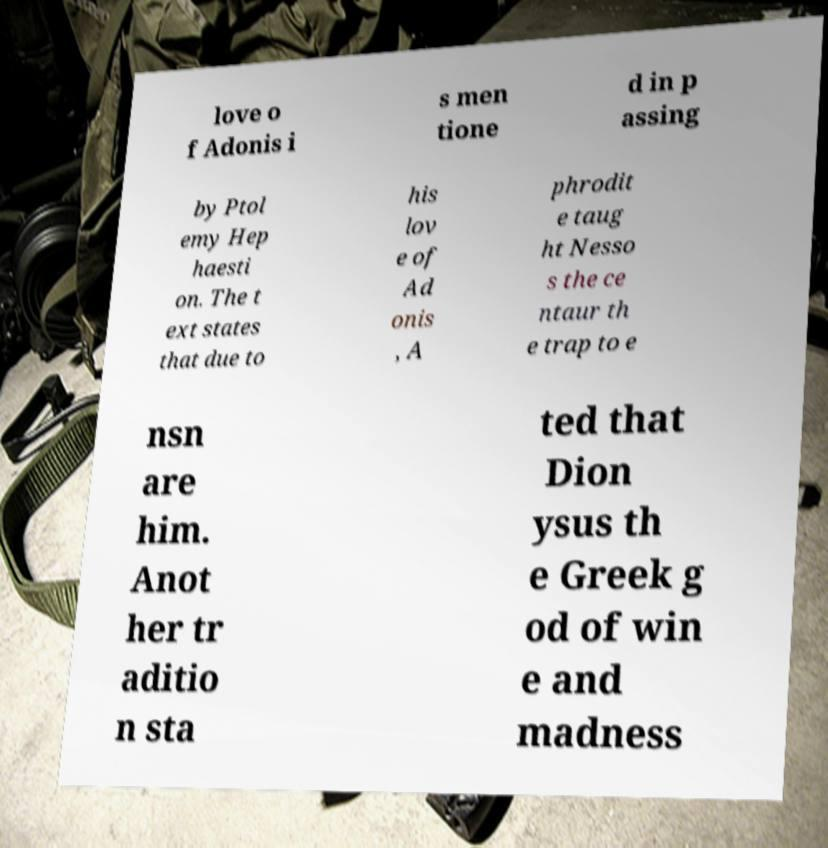For documentation purposes, I need the text within this image transcribed. Could you provide that? love o f Adonis i s men tione d in p assing by Ptol emy Hep haesti on. The t ext states that due to his lov e of Ad onis , A phrodit e taug ht Nesso s the ce ntaur th e trap to e nsn are him. Anot her tr aditio n sta ted that Dion ysus th e Greek g od of win e and madness 